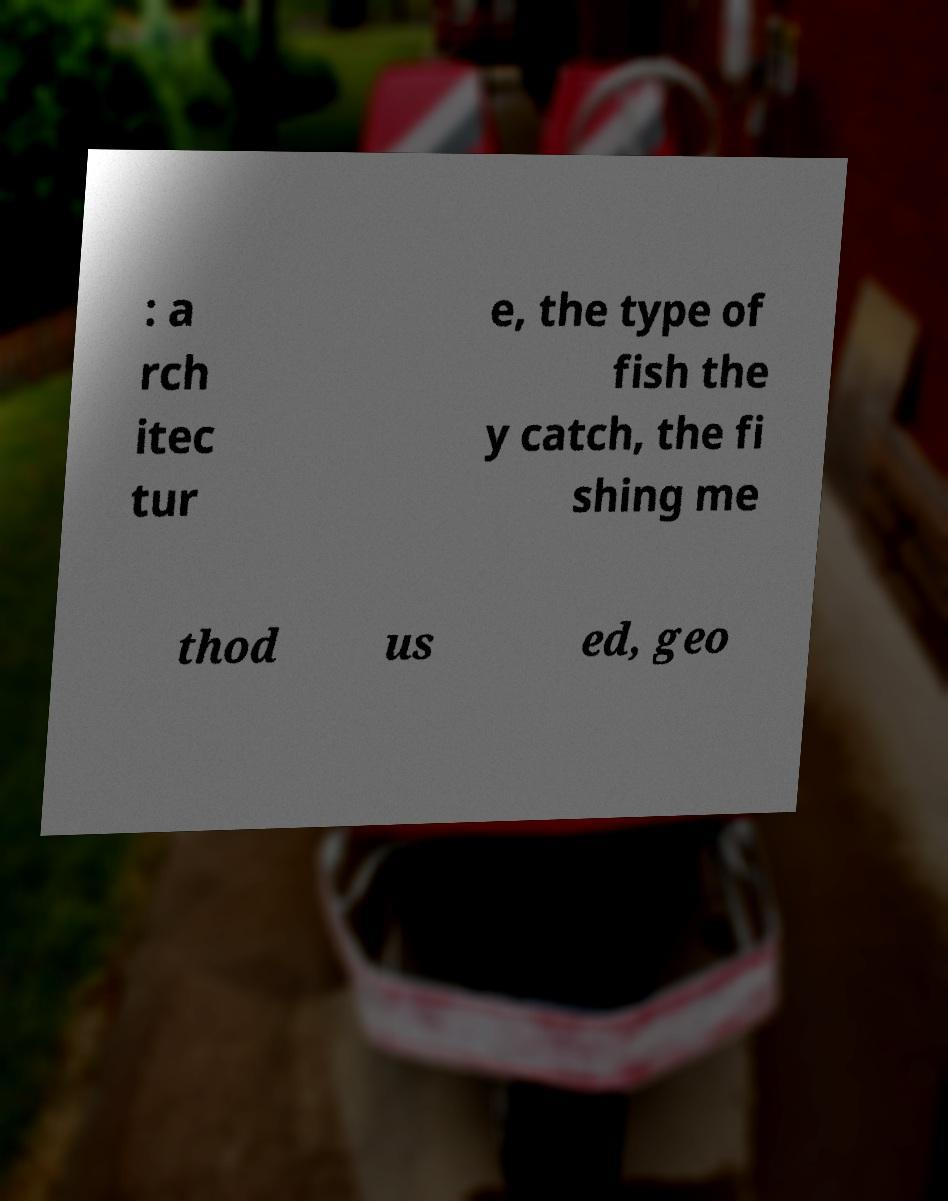Please read and relay the text visible in this image. What does it say? : a rch itec tur e, the type of fish the y catch, the fi shing me thod us ed, geo 